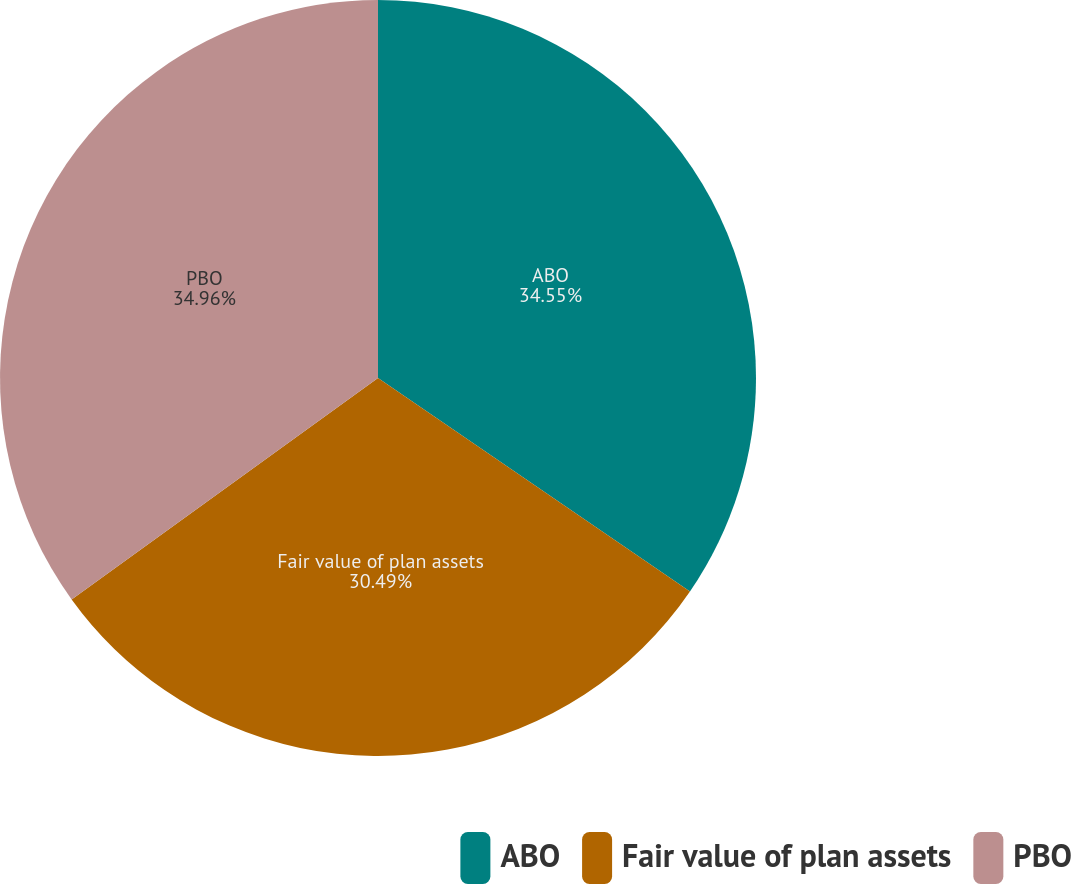<chart> <loc_0><loc_0><loc_500><loc_500><pie_chart><fcel>ABO<fcel>Fair value of plan assets<fcel>PBO<nl><fcel>34.55%<fcel>30.49%<fcel>34.96%<nl></chart> 